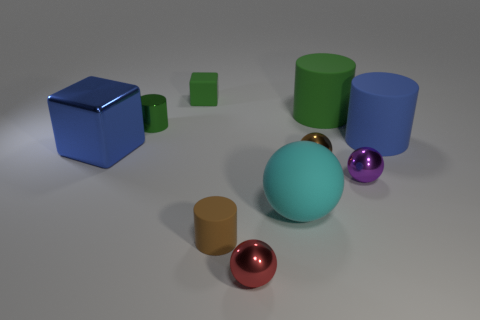Subtract all purple spheres. How many spheres are left? 3 Subtract all green cylinders. How many cylinders are left? 2 Subtract all cyan blocks. How many green cylinders are left? 2 Subtract all spheres. How many objects are left? 6 Subtract 2 blocks. How many blocks are left? 0 Subtract all gray cubes. Subtract all yellow cylinders. How many cubes are left? 2 Subtract all small blue rubber balls. Subtract all tiny brown cylinders. How many objects are left? 9 Add 8 brown shiny objects. How many brown shiny objects are left? 9 Add 6 big blue rubber cylinders. How many big blue rubber cylinders exist? 7 Subtract 0 yellow balls. How many objects are left? 10 